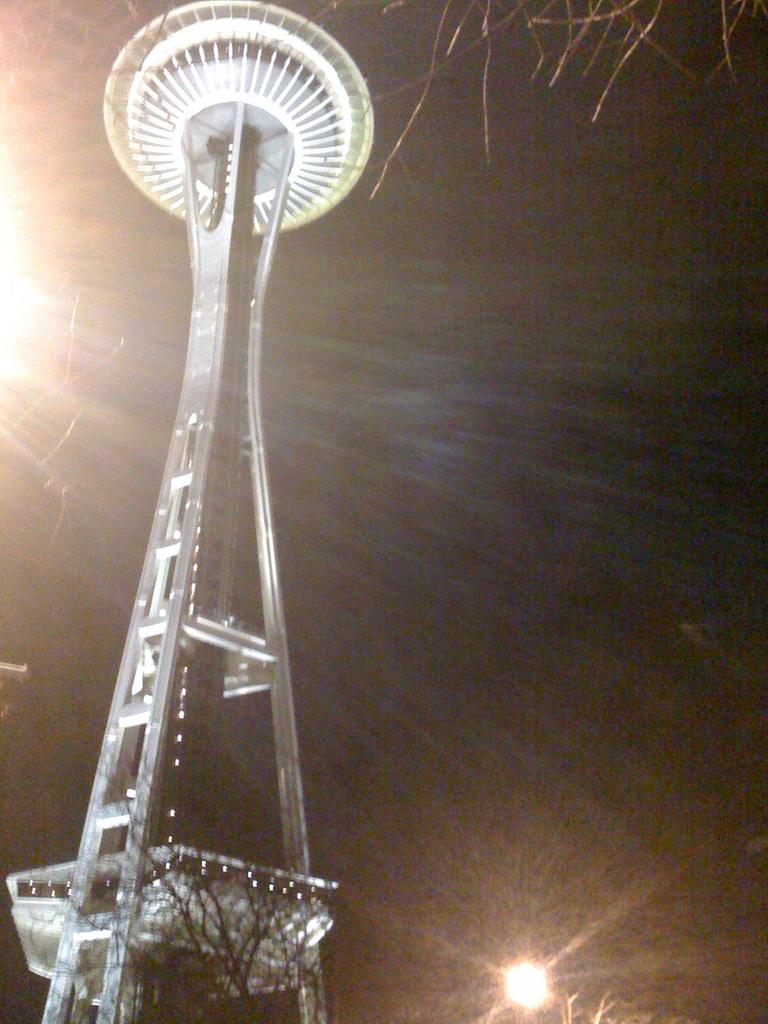What is the main structure in the image? There is a tower in the image. How many lights can be seen in the image? There are two lights in the image. What is the color of the background in the image? The background of the image is dark. What type of nail is being used to hang a painting in the image? There is no painting or nail present in the image; it only features a tower and two lights. 